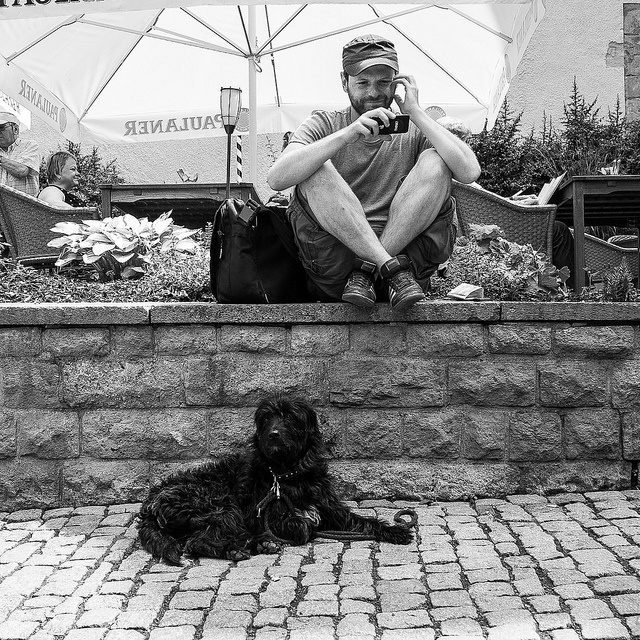Describe the objects in this image and their specific colors. I can see umbrella in black, white, darkgray, and gray tones, people in black, gray, darkgray, and lightgray tones, dog in black, gray, darkgray, and lightgray tones, backpack in black, gray, darkgray, and lightgray tones, and people in black, lightgray, darkgray, and gray tones in this image. 